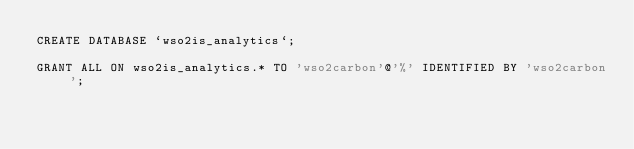<code> <loc_0><loc_0><loc_500><loc_500><_SQL_>CREATE DATABASE `wso2is_analytics`;

GRANT ALL ON wso2is_analytics.* TO 'wso2carbon'@'%' IDENTIFIED BY 'wso2carbon';
</code> 